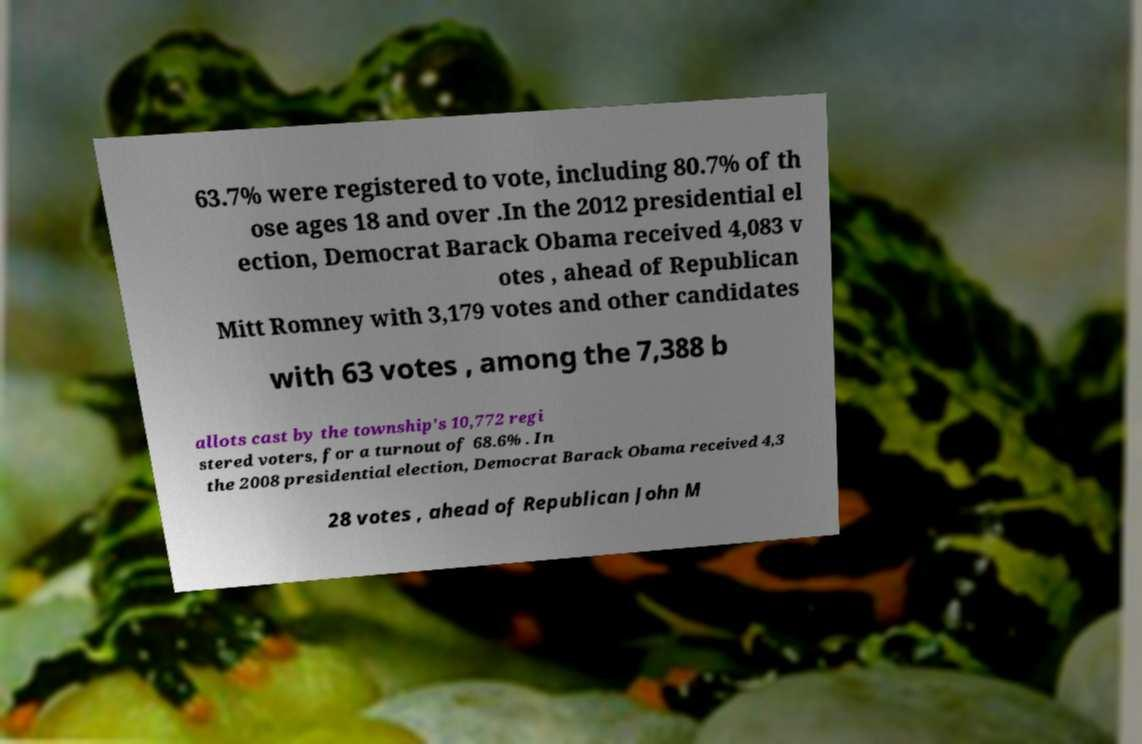Can you accurately transcribe the text from the provided image for me? 63.7% were registered to vote, including 80.7% of th ose ages 18 and over .In the 2012 presidential el ection, Democrat Barack Obama received 4,083 v otes , ahead of Republican Mitt Romney with 3,179 votes and other candidates with 63 votes , among the 7,388 b allots cast by the township's 10,772 regi stered voters, for a turnout of 68.6% . In the 2008 presidential election, Democrat Barack Obama received 4,3 28 votes , ahead of Republican John M 